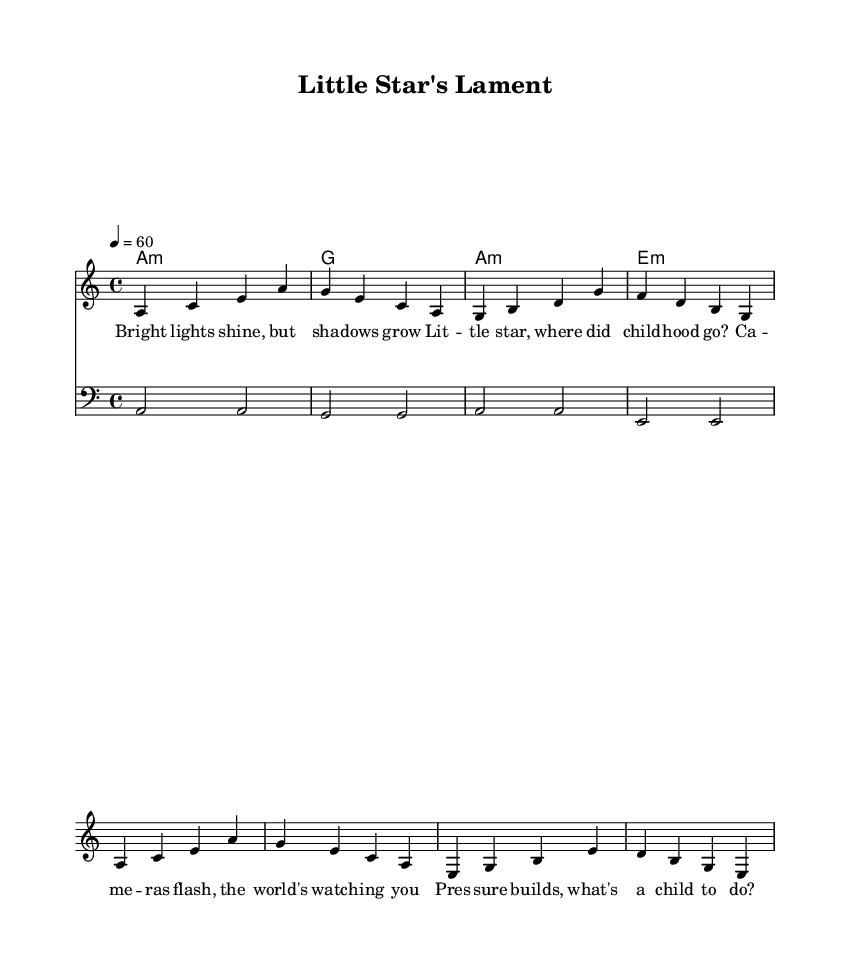What is the key signature of this music? The key signature is indicated at the beginning of the piece, which shows one flat (B). This means the key is A minor because it has no sharps or flats affecting the notes in the scale except for E.
Answer: A minor What is the time signature of this music? The time signature is presented at the beginning of the staff and is written as "4/4," which indicates a common time signature with four beats in each measure.
Answer: 4/4 What is the tempo marking of this piece? The tempo marking is provided within the score as "4 = 60." This indicates the speed at which the piece should be played, specifically that there are 60 quarter-note beats per minute.
Answer: 60 How many measures are in the melody? The melody section is visually divided into measures indicated by vertical lines. Counting these lines reveals that there are four measures in total.
Answer: Four What are the first two notes of the melody? The first two notes can be identified at the start of the melody. They are "a" and "c," which are located in the first measure.
Answer: A and C Which chord is played in the first measure? The chord played in the first measure is indicated in the chord mode section and shows an "A minor" chord, which corresponds with the melody notes played.
Answer: A minor What theme does the lyric text explore? The lyrics express themes of pressure and lost childhood in the context of fame, capturing the emotional weight of being in the spotlight at a young age.
Answer: Fame and pressure 